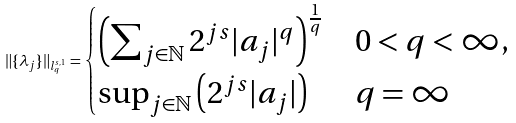<formula> <loc_0><loc_0><loc_500><loc_500>\| \{ \lambda _ { j } \} \| _ { l _ { q } ^ { s , 1 } } = \begin{cases} \left ( \sum _ { j \in \mathbb { N } } 2 ^ { j s } | a _ { j } | ^ { q } \right ) ^ { \frac { 1 } { q } } & 0 < q < \infty , \\ \sup _ { j \in \mathbb { N } } \left ( 2 ^ { j s } | a _ { j } | \right ) & q = \infty \end{cases}</formula> 